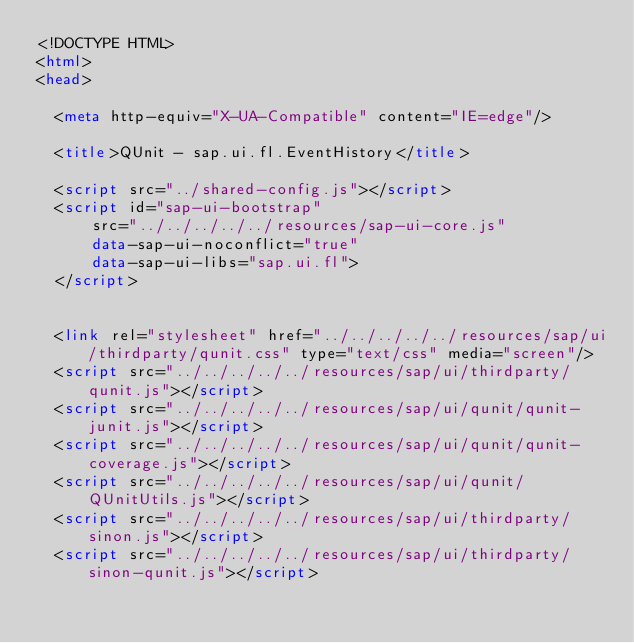<code> <loc_0><loc_0><loc_500><loc_500><_HTML_><!DOCTYPE HTML>
<html>
<head>

	<meta http-equiv="X-UA-Compatible" content="IE=edge"/>

	<title>QUnit - sap.ui.fl.EventHistory</title>

	<script src="../shared-config.js"></script>
	<script id="sap-ui-bootstrap"
			src="../../../../../resources/sap-ui-core.js"
			data-sap-ui-noconflict="true"
			data-sap-ui-libs="sap.ui.fl">
	</script>


	<link rel="stylesheet" href="../../../../../resources/sap/ui/thirdparty/qunit.css" type="text/css" media="screen"/>
	<script src="../../../../../resources/sap/ui/thirdparty/qunit.js"></script>
	<script src="../../../../../resources/sap/ui/qunit/qunit-junit.js"></script>
	<script src="../../../../../resources/sap/ui/qunit/qunit-coverage.js"></script>
	<script src="../../../../../resources/sap/ui/qunit/QUnitUtils.js"></script>
	<script src="../../../../../resources/sap/ui/thirdparty/sinon.js"></script>
	<script src="../../../../../resources/sap/ui/thirdparty/sinon-qunit.js"></script>
</code> 